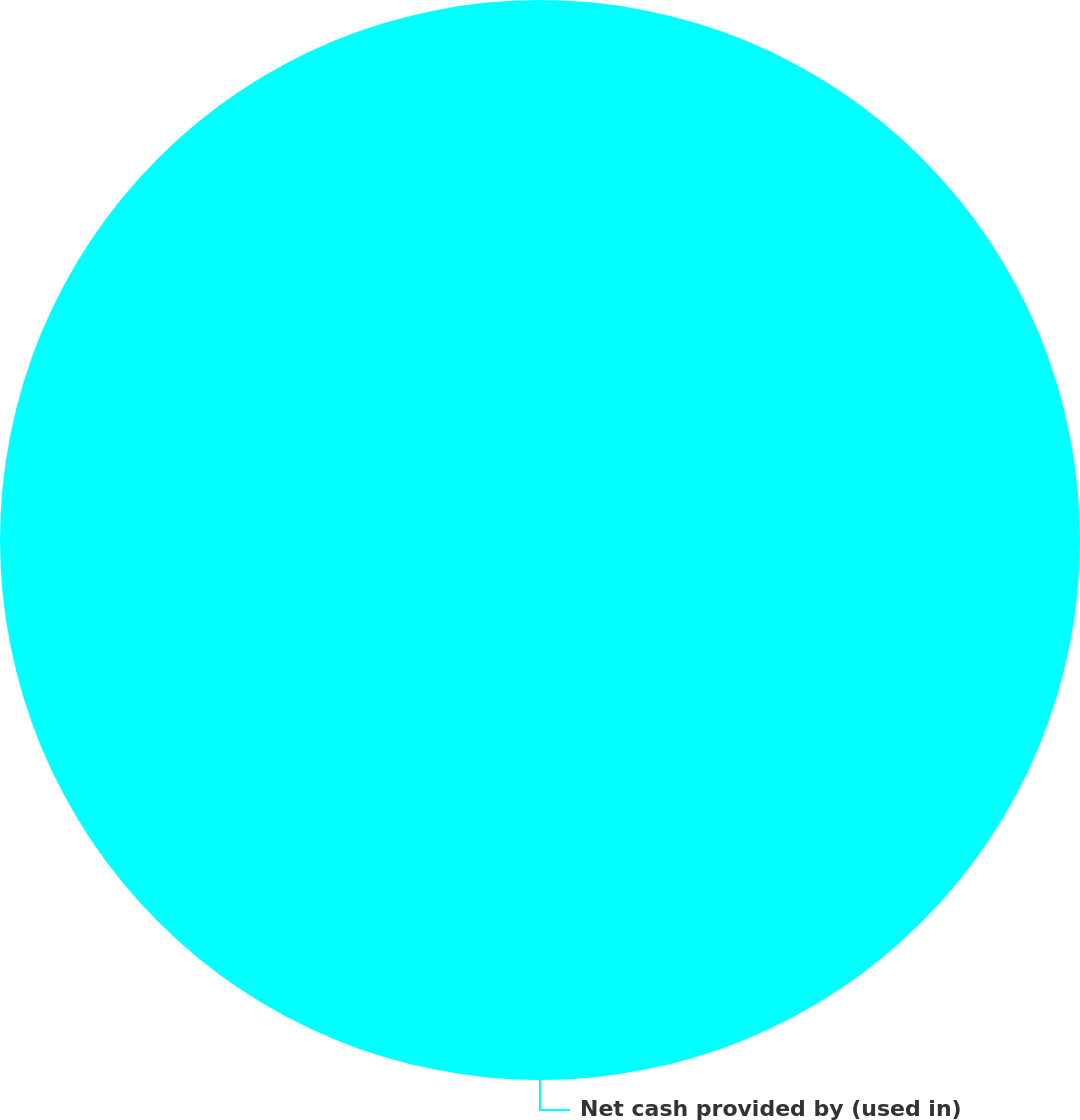<chart> <loc_0><loc_0><loc_500><loc_500><pie_chart><fcel>Net cash provided by (used in)<nl><fcel>100.0%<nl></chart> 